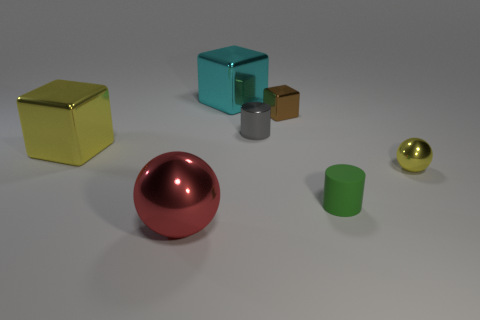How many red spheres have the same size as the yellow metallic cube?
Your response must be concise. 1. There is a big shiny cube behind the yellow metallic cube; is its color the same as the large sphere?
Give a very brief answer. No. What is the material of the thing that is in front of the large yellow thing and to the left of the cyan thing?
Provide a succinct answer. Metal. Are there more gray cylinders than cyan metallic cylinders?
Your answer should be compact. Yes. There is a big metal object behind the cube that is on the left side of the big cube that is behind the brown shiny cube; what is its color?
Ensure brevity in your answer.  Cyan. Does the object that is in front of the small rubber cylinder have the same material as the tiny sphere?
Give a very brief answer. Yes. Are there any metallic things of the same color as the metal cylinder?
Keep it short and to the point. No. Are any gray objects visible?
Give a very brief answer. Yes. Is the size of the metallic block left of the red object the same as the brown object?
Keep it short and to the point. No. Are there fewer metal cylinders than purple metallic things?
Your response must be concise. No. 